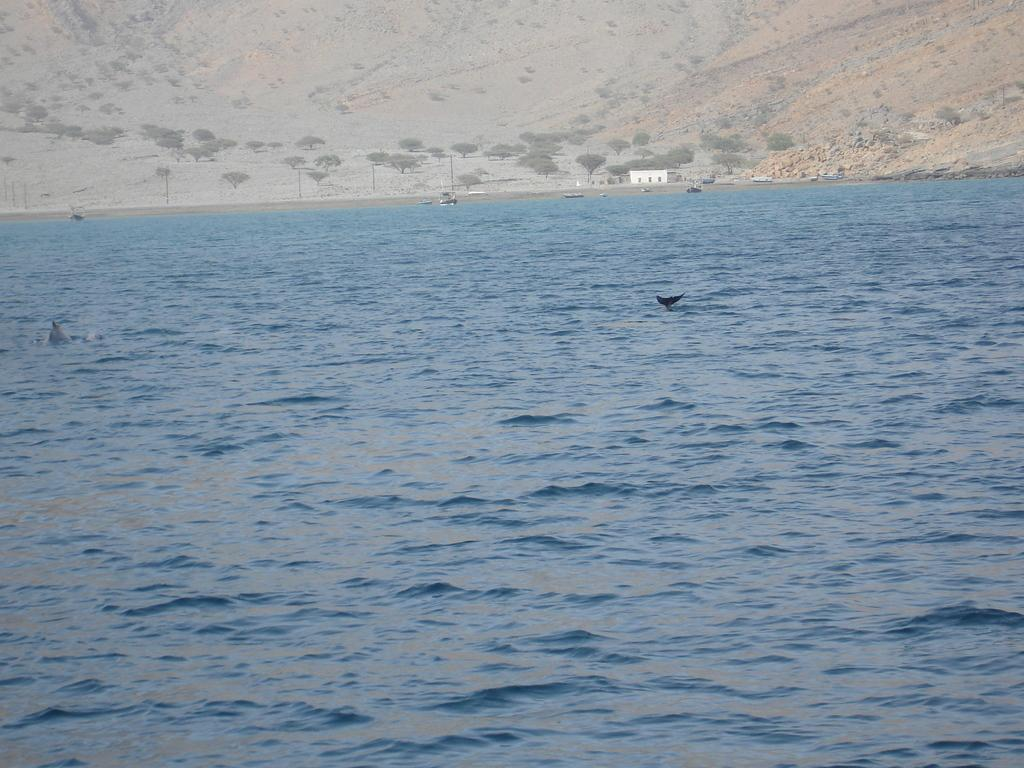What is happening on the water in the image? There are boats sailing on the surface of the water. What type of structure can be seen on the land? There is a house on the land. What natural elements are present around the house? The house has trees around it. What can be seen in the distance behind the house? There are hills visible in the background. What part of the city is the house located in the image? The image does not specify the location of the house in relation to a city or downtown area. Can you tell me a joke about the boats in the image? There is no joke provided in the image or the facts, as the focus is on describing the scene accurately. 